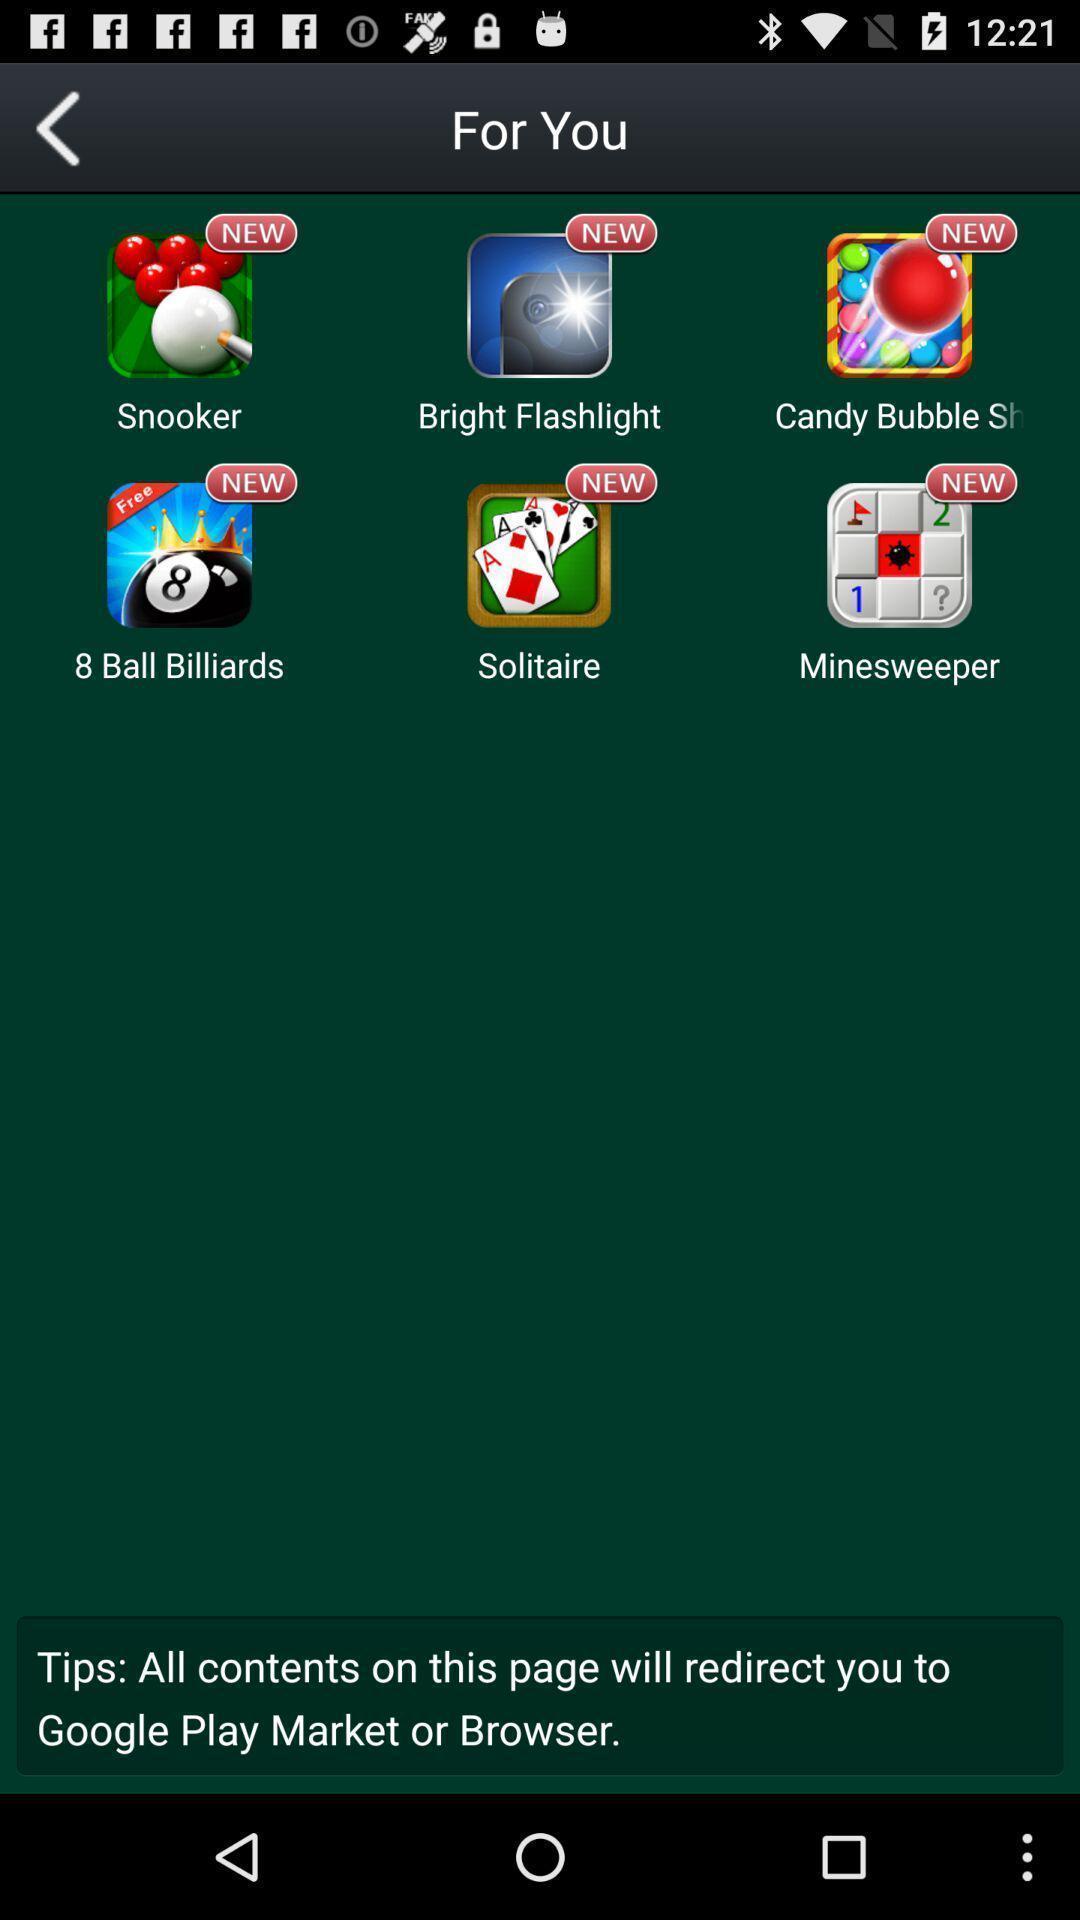Give me a narrative description of this picture. Various games page displayed. 